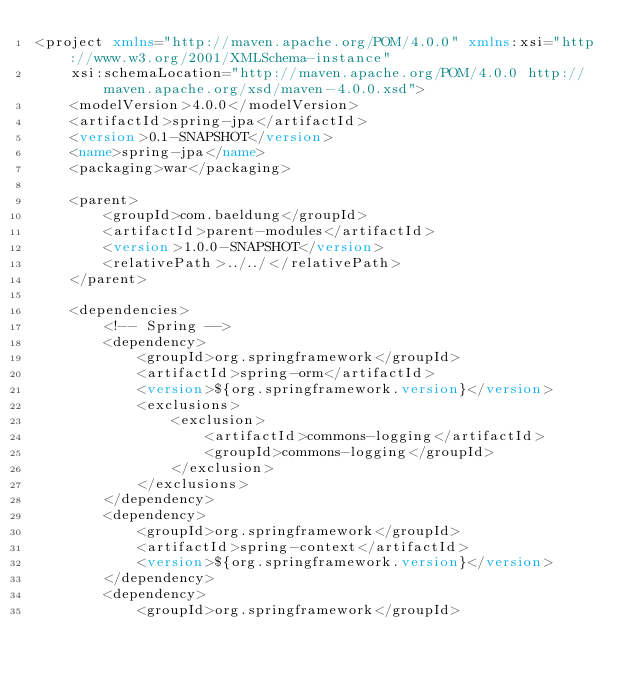Convert code to text. <code><loc_0><loc_0><loc_500><loc_500><_XML_><project xmlns="http://maven.apache.org/POM/4.0.0" xmlns:xsi="http://www.w3.org/2001/XMLSchema-instance"
    xsi:schemaLocation="http://maven.apache.org/POM/4.0.0 http://maven.apache.org/xsd/maven-4.0.0.xsd">
    <modelVersion>4.0.0</modelVersion>
    <artifactId>spring-jpa</artifactId>
    <version>0.1-SNAPSHOT</version>
    <name>spring-jpa</name>
    <packaging>war</packaging>

    <parent>
        <groupId>com.baeldung</groupId>
        <artifactId>parent-modules</artifactId>
        <version>1.0.0-SNAPSHOT</version>
        <relativePath>../../</relativePath>
    </parent>

    <dependencies>
        <!-- Spring -->
        <dependency>
            <groupId>org.springframework</groupId>
            <artifactId>spring-orm</artifactId>
            <version>${org.springframework.version}</version>
            <exclusions>
                <exclusion>
                    <artifactId>commons-logging</artifactId>
                    <groupId>commons-logging</groupId>
                </exclusion>
            </exclusions>
        </dependency>
        <dependency>
            <groupId>org.springframework</groupId>
            <artifactId>spring-context</artifactId>
            <version>${org.springframework.version}</version>
        </dependency>
        <dependency>
            <groupId>org.springframework</groupId></code> 